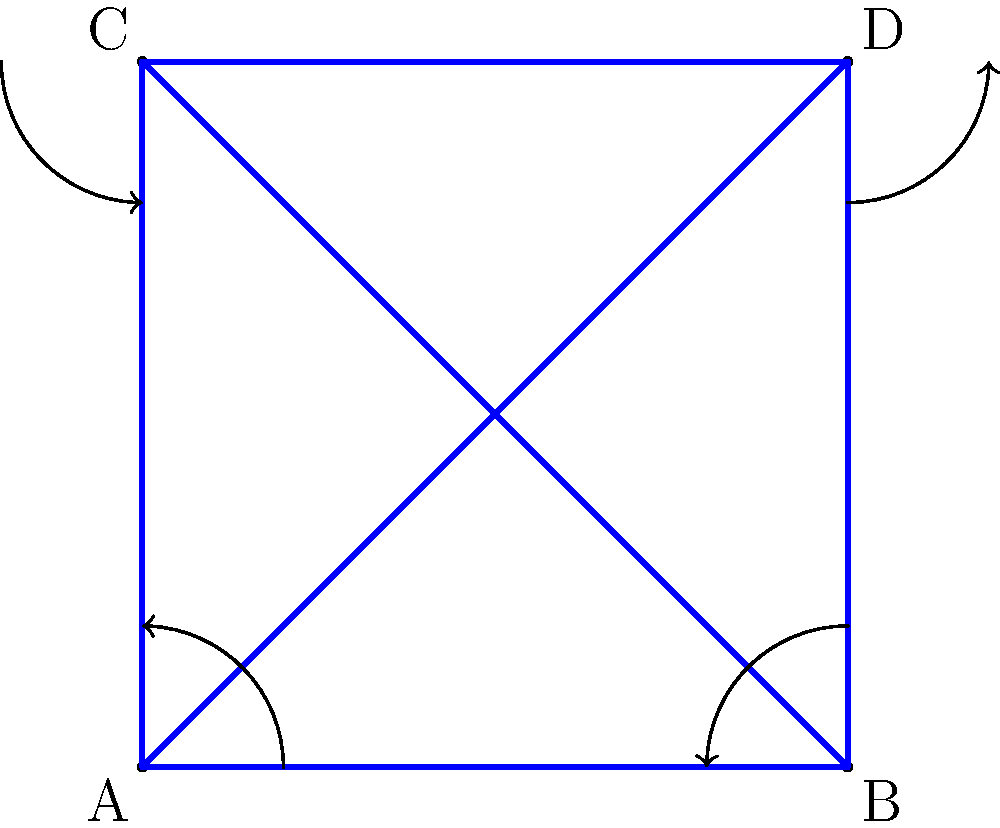Consider the group action of the cyclic group $C_4$ on the set of vertices $\{A, B, C, D\}$ of a square, where the group action corresponds to rotations by 90 degrees. Using the orbit-stabilizer theorem, calculate the size of the orbit of vertex A and explain how this relates to the order of the group and the size of the stabilizer of A. Let's approach this step-by-step:

1) First, recall the orbit-stabilizer theorem: For a group $G$ acting on a set $X$, and an element $x \in X$, we have:

   $|G| = |Orb(x)| \cdot |Stab(x)|$

   where $|G|$ is the order of the group, $|Orb(x)|$ is the size of the orbit of $x$, and $|Stab(x)|$ is the size of the stabilizer of $x$.

2) In this case, $G = C_4$, the cyclic group of order 4, and $X = \{A, B, C, D\}$.

3) Let's determine the orbit of A:
   - Under the identity rotation: A stays at A
   - Under 90° rotation: A moves to B
   - Under 180° rotation: A moves to D
   - Under 270° rotation: A moves to C

   So, $Orb(A) = \{A, B, C, D\}$ and $|Orb(A)| = 4$

4) We know that $|G| = |C_4| = 4$

5) Using the orbit-stabilizer theorem:

   $4 = |Orb(A)| \cdot |Stab(A)|$
   $4 = 4 \cdot |Stab(A)|$

6) Solving for $|Stab(A)|$:

   $|Stab(A)| = 1$

7) This makes sense because only the identity rotation leaves A fixed.

8) We can see that the size of the orbit (4) multiplied by the size of the stabilizer (1) equals the order of the group (4), which is exactly what the orbit-stabilizer theorem states.
Answer: $|Orb(A)| = 4$, $|Stab(A)| = 1$ 